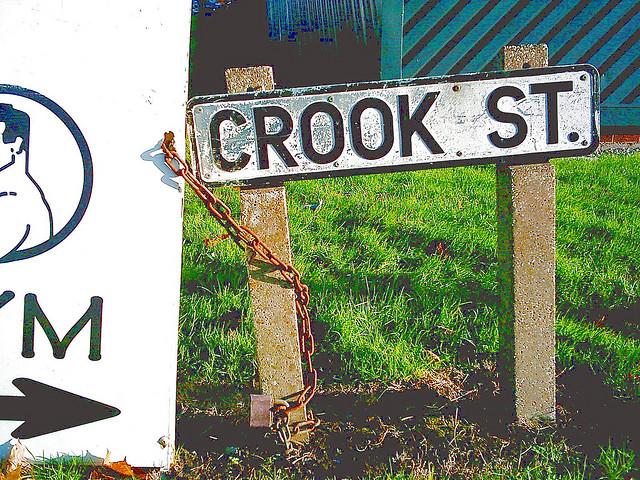What is cast?
Quick response, please. Sign. Is the chain rusty?
Give a very brief answer. Yes. Is there another word for criminal here?
Keep it brief. Yes. 